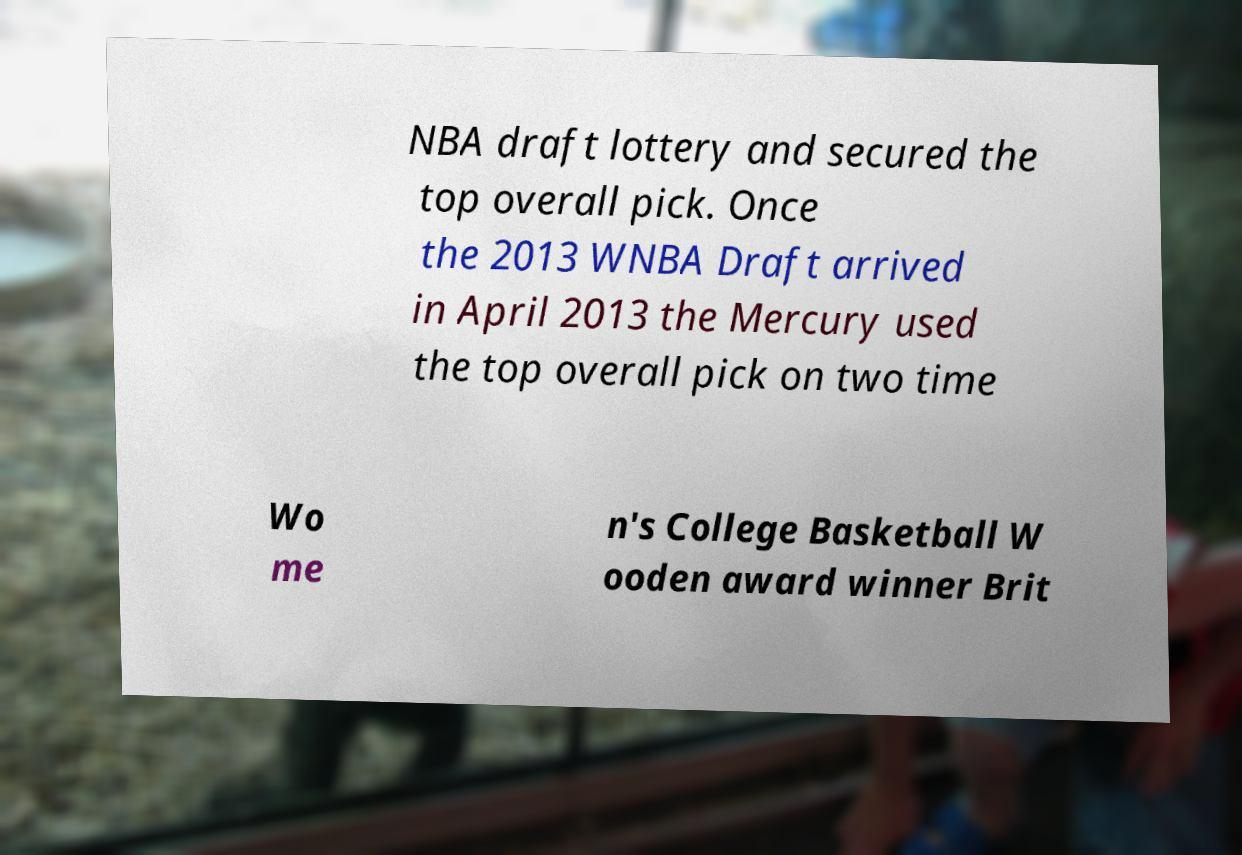Can you accurately transcribe the text from the provided image for me? NBA draft lottery and secured the top overall pick. Once the 2013 WNBA Draft arrived in April 2013 the Mercury used the top overall pick on two time Wo me n's College Basketball W ooden award winner Brit 